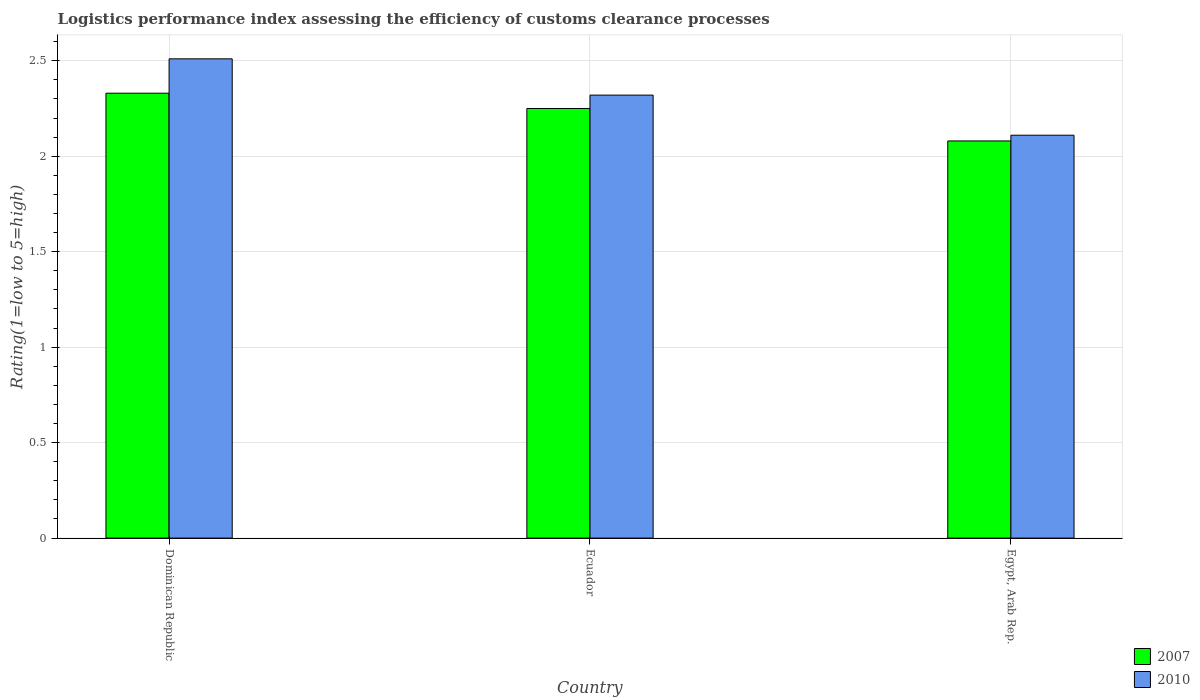How many different coloured bars are there?
Offer a terse response. 2. How many groups of bars are there?
Ensure brevity in your answer.  3. Are the number of bars per tick equal to the number of legend labels?
Ensure brevity in your answer.  Yes. Are the number of bars on each tick of the X-axis equal?
Offer a very short reply. Yes. What is the label of the 3rd group of bars from the left?
Your response must be concise. Egypt, Arab Rep. In how many cases, is the number of bars for a given country not equal to the number of legend labels?
Make the answer very short. 0. What is the Logistic performance index in 2007 in Egypt, Arab Rep.?
Make the answer very short. 2.08. Across all countries, what is the maximum Logistic performance index in 2007?
Provide a succinct answer. 2.33. Across all countries, what is the minimum Logistic performance index in 2007?
Offer a terse response. 2.08. In which country was the Logistic performance index in 2007 maximum?
Your response must be concise. Dominican Republic. In which country was the Logistic performance index in 2010 minimum?
Ensure brevity in your answer.  Egypt, Arab Rep. What is the total Logistic performance index in 2010 in the graph?
Provide a short and direct response. 6.94. What is the difference between the Logistic performance index in 2007 in Ecuador and that in Egypt, Arab Rep.?
Offer a very short reply. 0.17. What is the difference between the Logistic performance index in 2007 in Ecuador and the Logistic performance index in 2010 in Egypt, Arab Rep.?
Provide a succinct answer. 0.14. What is the average Logistic performance index in 2010 per country?
Your answer should be compact. 2.31. What is the difference between the Logistic performance index of/in 2010 and Logistic performance index of/in 2007 in Egypt, Arab Rep.?
Offer a very short reply. 0.03. What is the ratio of the Logistic performance index in 2007 in Dominican Republic to that in Ecuador?
Provide a short and direct response. 1.04. Is the difference between the Logistic performance index in 2010 in Ecuador and Egypt, Arab Rep. greater than the difference between the Logistic performance index in 2007 in Ecuador and Egypt, Arab Rep.?
Give a very brief answer. Yes. What is the difference between the highest and the second highest Logistic performance index in 2010?
Offer a very short reply. -0.4. What is the difference between the highest and the lowest Logistic performance index in 2010?
Offer a very short reply. 0.4. In how many countries, is the Logistic performance index in 2010 greater than the average Logistic performance index in 2010 taken over all countries?
Provide a succinct answer. 2. Is the sum of the Logistic performance index in 2007 in Dominican Republic and Egypt, Arab Rep. greater than the maximum Logistic performance index in 2010 across all countries?
Offer a very short reply. Yes. What does the 2nd bar from the left in Egypt, Arab Rep. represents?
Offer a terse response. 2010. How many countries are there in the graph?
Your answer should be very brief. 3. Does the graph contain grids?
Provide a short and direct response. Yes. How are the legend labels stacked?
Provide a short and direct response. Vertical. What is the title of the graph?
Provide a short and direct response. Logistics performance index assessing the efficiency of customs clearance processes. What is the label or title of the X-axis?
Your answer should be compact. Country. What is the label or title of the Y-axis?
Provide a short and direct response. Rating(1=low to 5=high). What is the Rating(1=low to 5=high) in 2007 in Dominican Republic?
Provide a short and direct response. 2.33. What is the Rating(1=low to 5=high) of 2010 in Dominican Republic?
Give a very brief answer. 2.51. What is the Rating(1=low to 5=high) in 2007 in Ecuador?
Ensure brevity in your answer.  2.25. What is the Rating(1=low to 5=high) in 2010 in Ecuador?
Ensure brevity in your answer.  2.32. What is the Rating(1=low to 5=high) in 2007 in Egypt, Arab Rep.?
Offer a very short reply. 2.08. What is the Rating(1=low to 5=high) of 2010 in Egypt, Arab Rep.?
Offer a very short reply. 2.11. Across all countries, what is the maximum Rating(1=low to 5=high) in 2007?
Offer a terse response. 2.33. Across all countries, what is the maximum Rating(1=low to 5=high) in 2010?
Your response must be concise. 2.51. Across all countries, what is the minimum Rating(1=low to 5=high) in 2007?
Provide a succinct answer. 2.08. Across all countries, what is the minimum Rating(1=low to 5=high) of 2010?
Keep it short and to the point. 2.11. What is the total Rating(1=low to 5=high) in 2007 in the graph?
Your answer should be very brief. 6.66. What is the total Rating(1=low to 5=high) of 2010 in the graph?
Provide a short and direct response. 6.94. What is the difference between the Rating(1=low to 5=high) of 2007 in Dominican Republic and that in Ecuador?
Provide a short and direct response. 0.08. What is the difference between the Rating(1=low to 5=high) of 2010 in Dominican Republic and that in Ecuador?
Your answer should be very brief. 0.19. What is the difference between the Rating(1=low to 5=high) of 2007 in Ecuador and that in Egypt, Arab Rep.?
Provide a succinct answer. 0.17. What is the difference between the Rating(1=low to 5=high) in 2010 in Ecuador and that in Egypt, Arab Rep.?
Give a very brief answer. 0.21. What is the difference between the Rating(1=low to 5=high) in 2007 in Dominican Republic and the Rating(1=low to 5=high) in 2010 in Ecuador?
Provide a short and direct response. 0.01. What is the difference between the Rating(1=low to 5=high) of 2007 in Dominican Republic and the Rating(1=low to 5=high) of 2010 in Egypt, Arab Rep.?
Offer a terse response. 0.22. What is the difference between the Rating(1=low to 5=high) in 2007 in Ecuador and the Rating(1=low to 5=high) in 2010 in Egypt, Arab Rep.?
Make the answer very short. 0.14. What is the average Rating(1=low to 5=high) in 2007 per country?
Give a very brief answer. 2.22. What is the average Rating(1=low to 5=high) in 2010 per country?
Your response must be concise. 2.31. What is the difference between the Rating(1=low to 5=high) in 2007 and Rating(1=low to 5=high) in 2010 in Dominican Republic?
Provide a short and direct response. -0.18. What is the difference between the Rating(1=low to 5=high) of 2007 and Rating(1=low to 5=high) of 2010 in Ecuador?
Your response must be concise. -0.07. What is the difference between the Rating(1=low to 5=high) of 2007 and Rating(1=low to 5=high) of 2010 in Egypt, Arab Rep.?
Ensure brevity in your answer.  -0.03. What is the ratio of the Rating(1=low to 5=high) in 2007 in Dominican Republic to that in Ecuador?
Your answer should be very brief. 1.04. What is the ratio of the Rating(1=low to 5=high) of 2010 in Dominican Republic to that in Ecuador?
Your answer should be compact. 1.08. What is the ratio of the Rating(1=low to 5=high) in 2007 in Dominican Republic to that in Egypt, Arab Rep.?
Provide a succinct answer. 1.12. What is the ratio of the Rating(1=low to 5=high) of 2010 in Dominican Republic to that in Egypt, Arab Rep.?
Keep it short and to the point. 1.19. What is the ratio of the Rating(1=low to 5=high) of 2007 in Ecuador to that in Egypt, Arab Rep.?
Your response must be concise. 1.08. What is the ratio of the Rating(1=low to 5=high) of 2010 in Ecuador to that in Egypt, Arab Rep.?
Provide a succinct answer. 1.1. What is the difference between the highest and the second highest Rating(1=low to 5=high) in 2007?
Your answer should be compact. 0.08. What is the difference between the highest and the second highest Rating(1=low to 5=high) of 2010?
Ensure brevity in your answer.  0.19. 